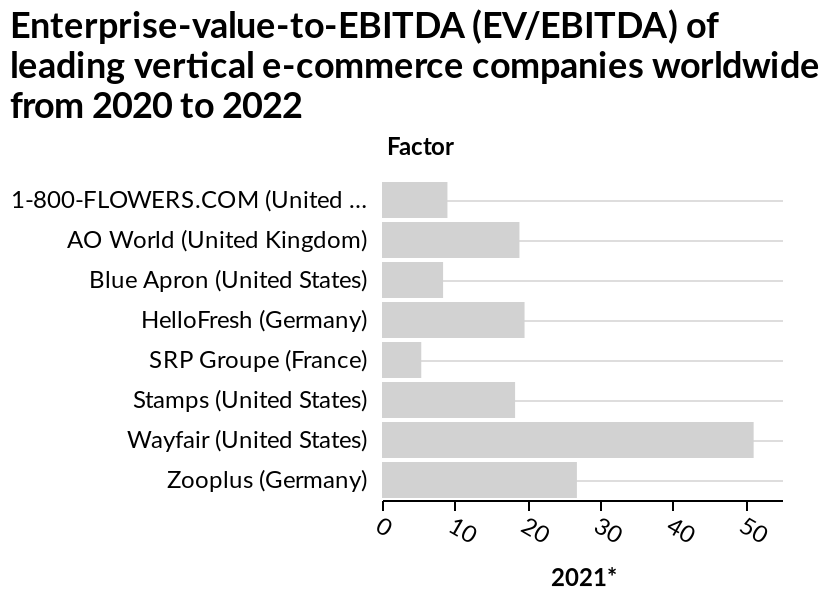<image>
Which company has the highest number in the figure? Wayfair What is the title of the bar diagram?  The title of the bar diagram is "Enterprise-value-to-EBITDA (EV/EBITDA) of leading vertical e-commerce companies worldwide". Offer a thorough analysis of the image. Wayfair is in the lead with 50 whereas SRP Groupe is showing the east at 5. There are 8 companies on the list. The companies are listed in alphabetical order from top to bottom. The United States has the most companies listed with 4 different ones. The least companies listed are from the United Kingdom and France with only 1 each. 